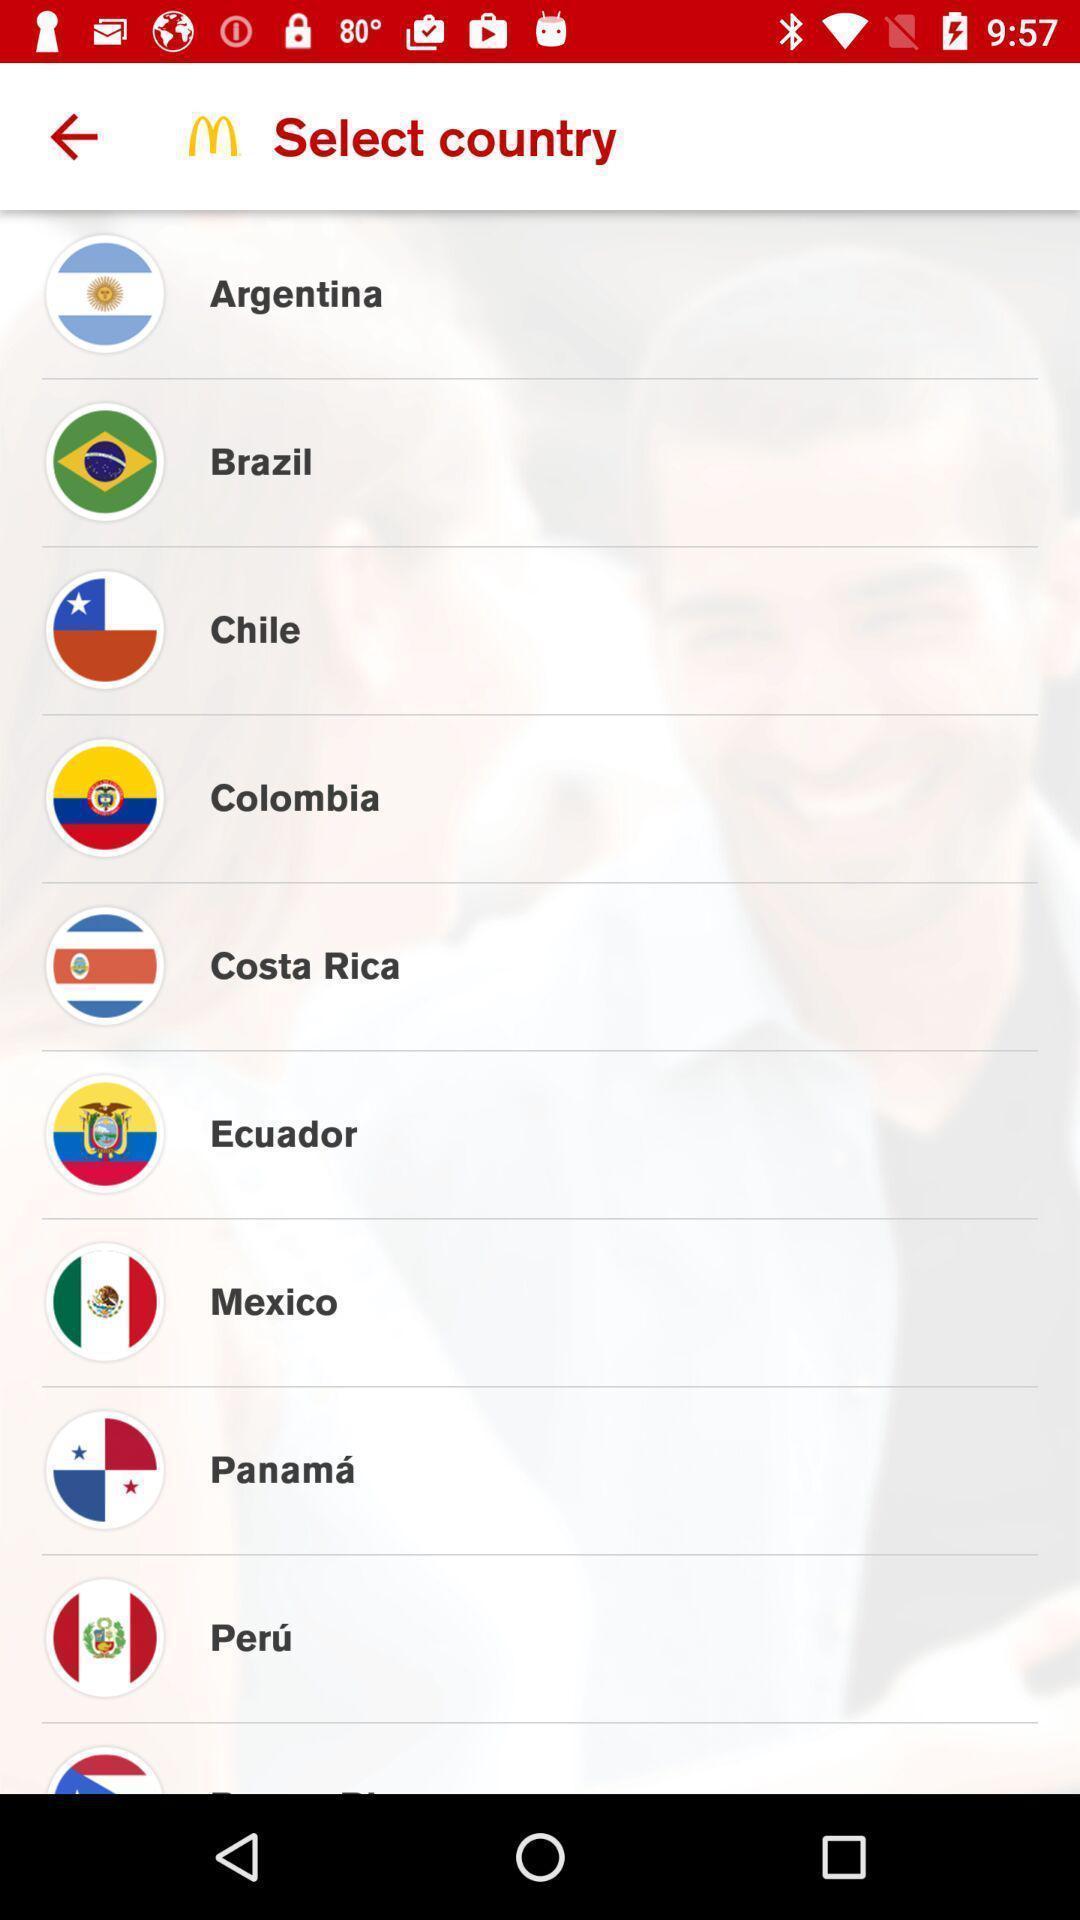Describe the key features of this screenshot. Screen displaying a list of multiple country names. 